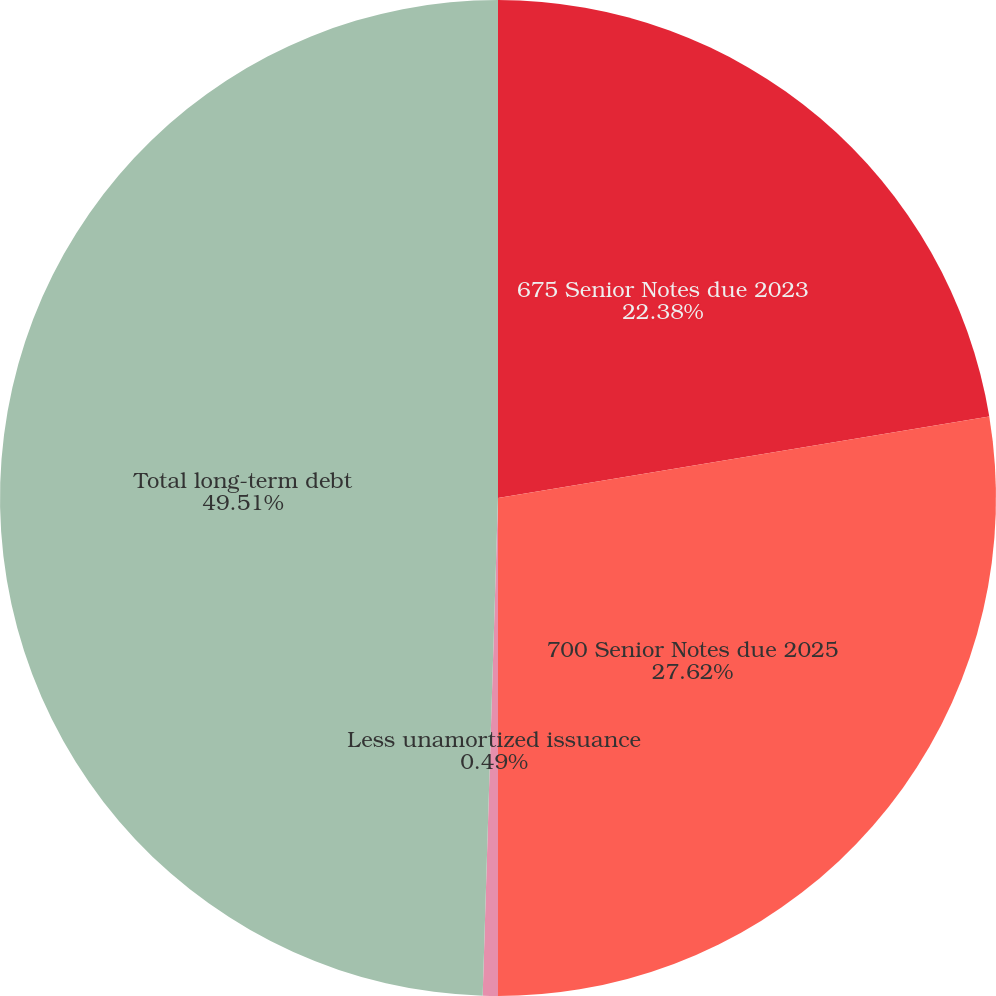Convert chart to OTSL. <chart><loc_0><loc_0><loc_500><loc_500><pie_chart><fcel>675 Senior Notes due 2023<fcel>700 Senior Notes due 2025<fcel>Less unamortized issuance<fcel>Total long-term debt<nl><fcel>22.38%<fcel>27.62%<fcel>0.49%<fcel>49.51%<nl></chart> 